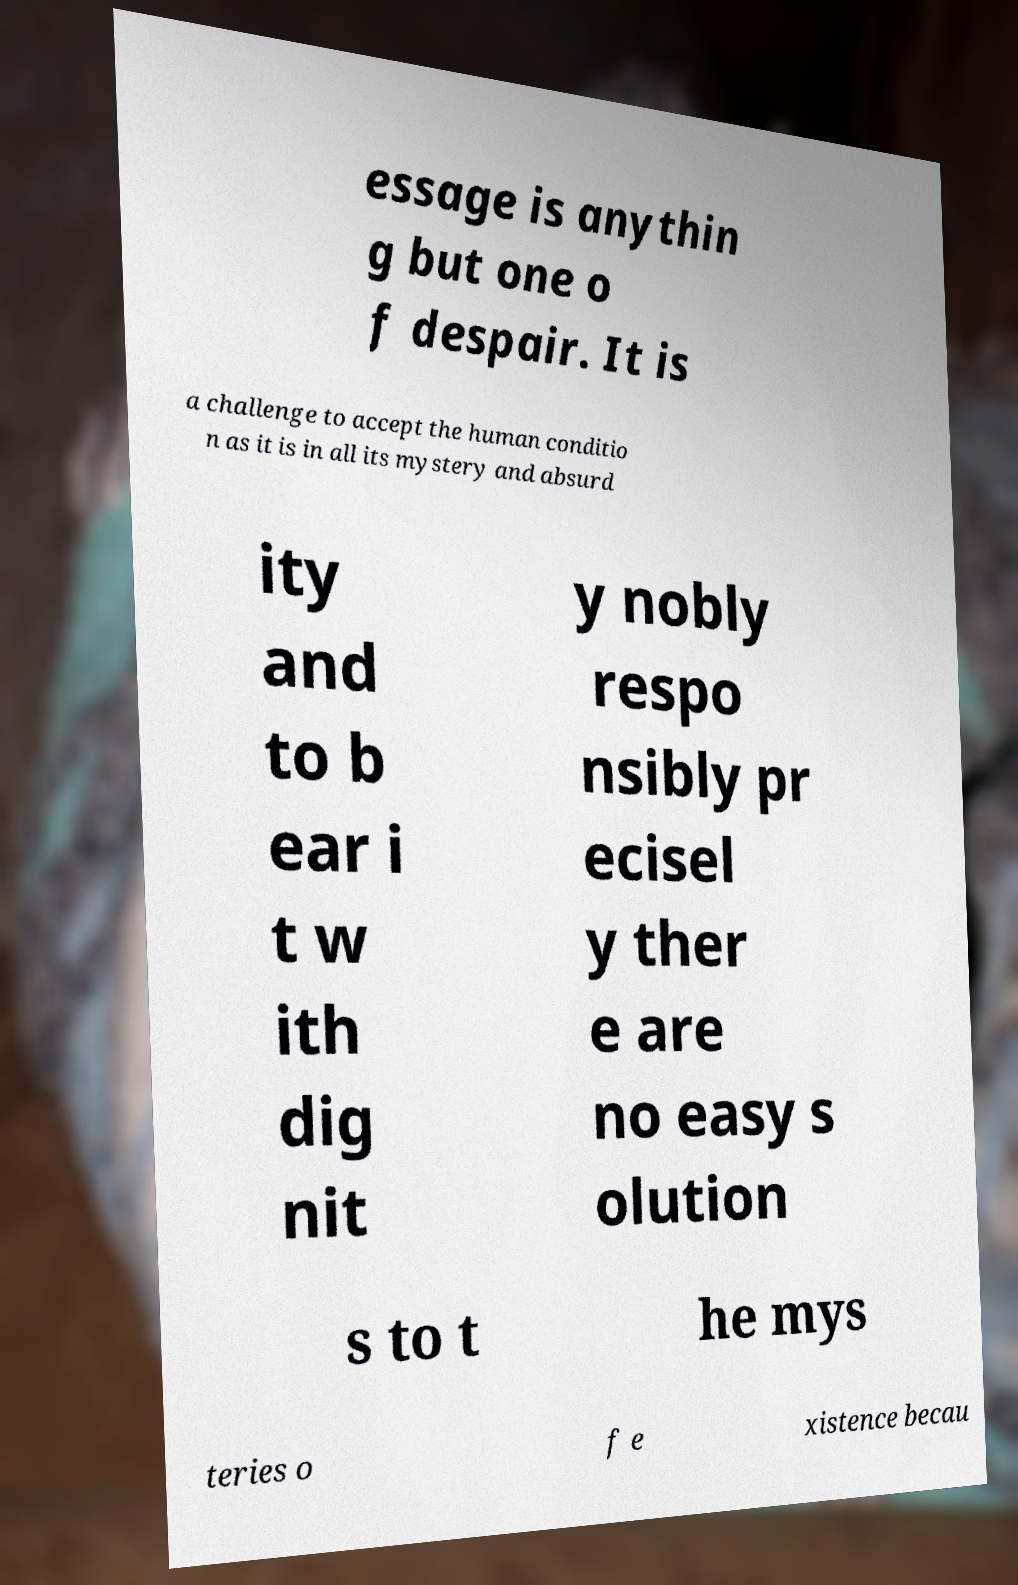Please identify and transcribe the text found in this image. essage is anythin g but one o f despair. It is a challenge to accept the human conditio n as it is in all its mystery and absurd ity and to b ear i t w ith dig nit y nobly respo nsibly pr ecisel y ther e are no easy s olution s to t he mys teries o f e xistence becau 